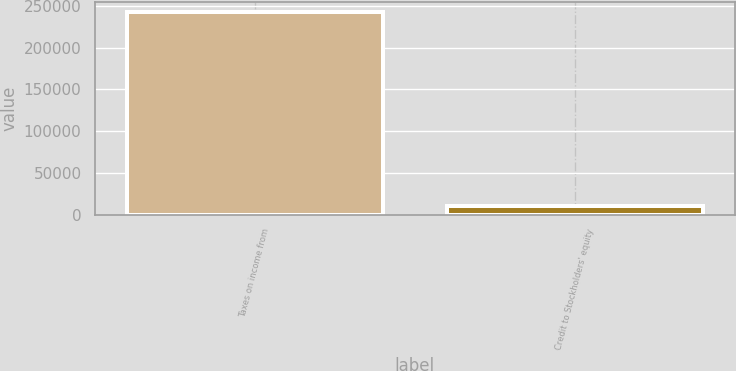Convert chart to OTSL. <chart><loc_0><loc_0><loc_500><loc_500><bar_chart><fcel>Taxes on income from<fcel>Credit to Stockholders' equity<nl><fcel>242617<fcel>10319<nl></chart> 